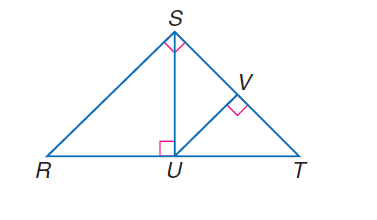Question: If \angle R S T is a right angle, S U \perp R T, U V \perp S T, and m \angle R T S = 47, find m \angle R S U.
Choices:
A. 35
B. 37
C. 45
D. 47
Answer with the letter. Answer: D Question: If \angle R S T is a right angle, S U \perp R T, U V \perp S T, and m \angle R T S = 47, find m \angle R.
Choices:
A. 25
B. 33
C. 40
D. 43
Answer with the letter. Answer: D Question: If \angle R S T is a right angle, S U \perp R T, U V \perp S T, and m \angle R T S = 47, find m \angle T U V.
Choices:
A. 37
B. 40
C. 43
D. 45
Answer with the letter. Answer: C Question: If \angle R S T is a right angle, S U \perp R T, U V \perp S T, and m \angle R T S = 47, find m \angle S U V.
Choices:
A. 47
B. 53
C. 55
D. 66
Answer with the letter. Answer: A 